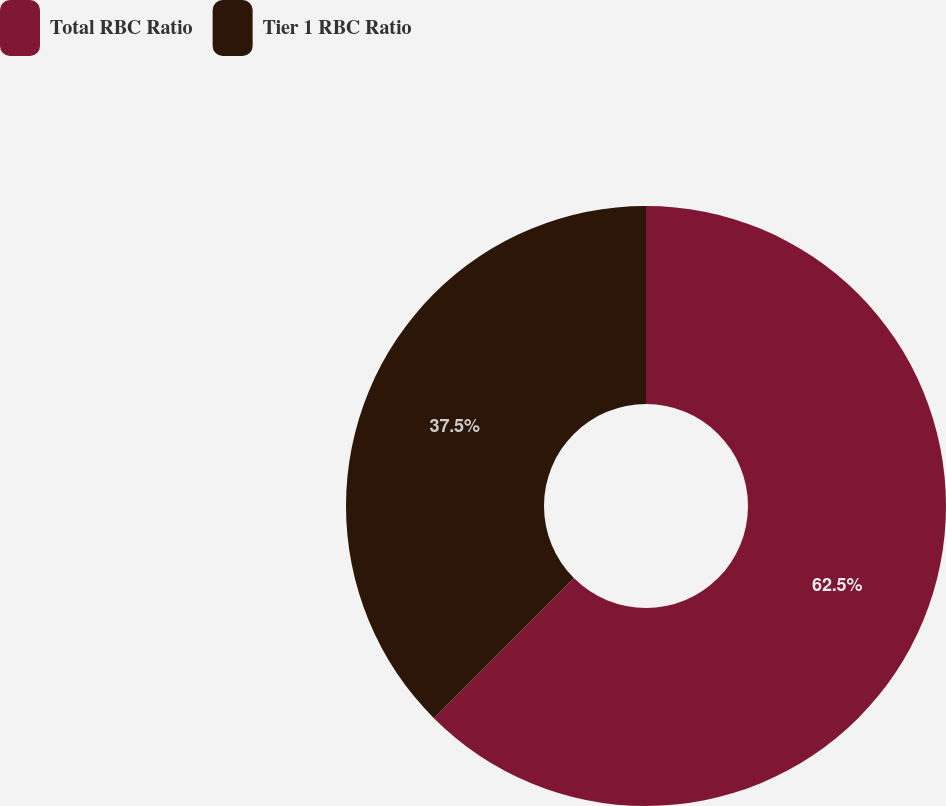<chart> <loc_0><loc_0><loc_500><loc_500><pie_chart><fcel>Total RBC Ratio<fcel>Tier 1 RBC Ratio<nl><fcel>62.5%<fcel>37.5%<nl></chart> 